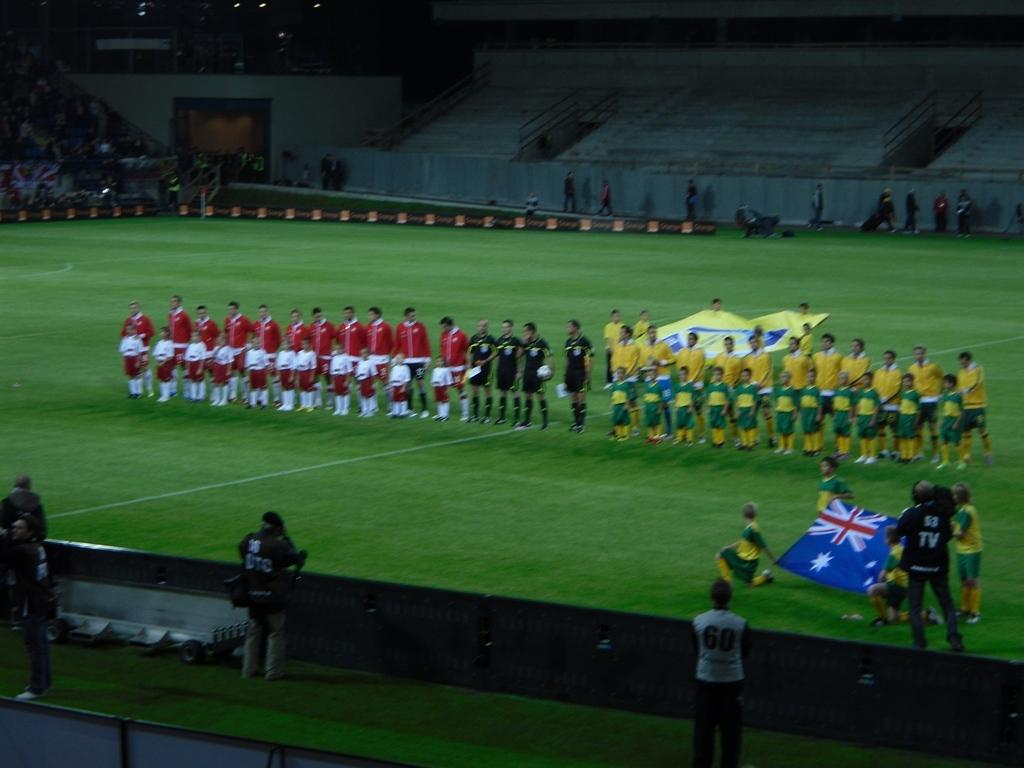<image>
Describe the image concisely. A person wearing a shirt that says TV on the back watches players from both soccer teams gather at midfield. 